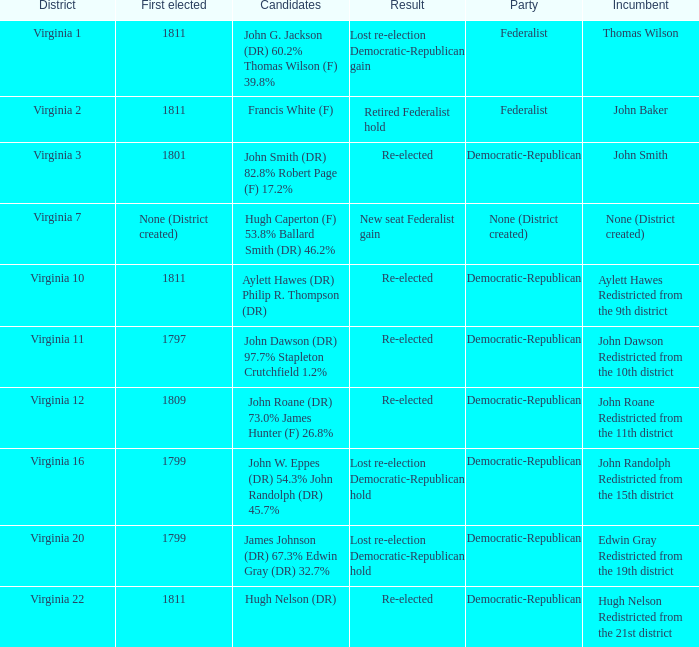Name the party for virginia 12 Democratic-Republican. 